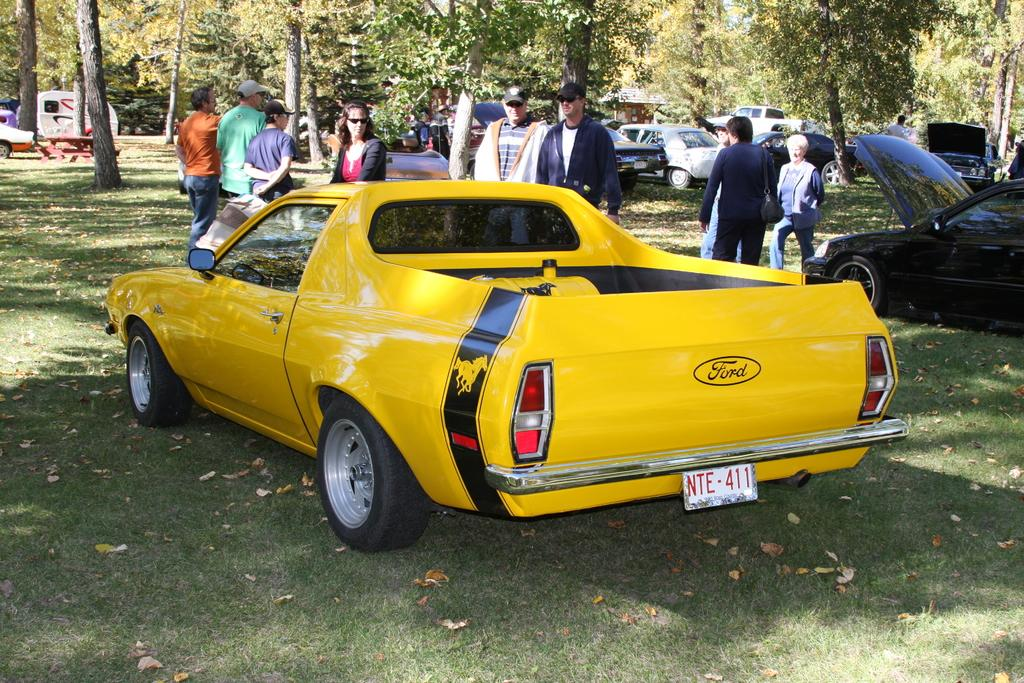What types of objects can be seen in the image? There are vehicles, trees, people, and benches in the image. What is the ground like in the image? The ground is visible in the image, and there is grass on it. Can you describe the white colored object in the image? There is a white colored object in the image, but it is not clear what it is from the provided facts. How does love affect the vehicles in the image? There is no indication of love or its effects on the vehicles in the image. Are the people in the image wearing masks? There is no information about masks or their presence on the people in the image. 